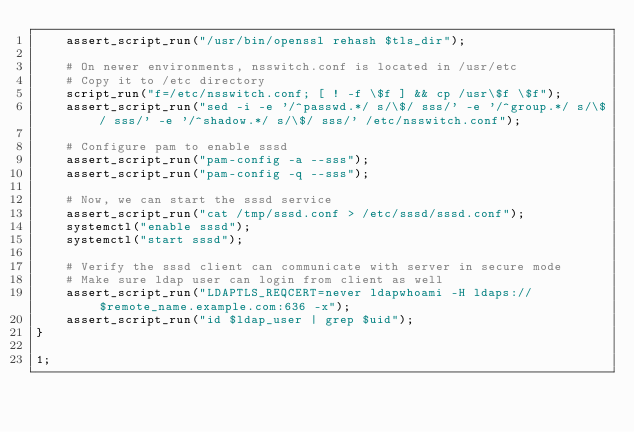Convert code to text. <code><loc_0><loc_0><loc_500><loc_500><_Perl_>    assert_script_run("/usr/bin/openssl rehash $tls_dir");

    # On newer environments, nsswitch.conf is located in /usr/etc
    # Copy it to /etc directory
    script_run("f=/etc/nsswitch.conf; [ ! -f \$f ] && cp /usr\$f \$f");
    assert_script_run("sed -i -e '/^passwd.*/ s/\$/ sss/' -e '/^group.*/ s/\$/ sss/' -e '/^shadow.*/ s/\$/ sss/' /etc/nsswitch.conf");

    # Configure pam to enable sssd
    assert_script_run("pam-config -a --sss");
    assert_script_run("pam-config -q --sss");

    # Now, we can start the sssd service
    assert_script_run("cat /tmp/sssd.conf > /etc/sssd/sssd.conf");
    systemctl("enable sssd");
    systemctl("start sssd");

    # Verify the sssd client can communicate with server in secure mode
    # Make sure ldap user can login from client as well
    assert_script_run("LDAPTLS_REQCERT=never ldapwhoami -H ldaps://$remote_name.example.com:636 -x");
    assert_script_run("id $ldap_user | grep $uid");
}

1;
</code> 